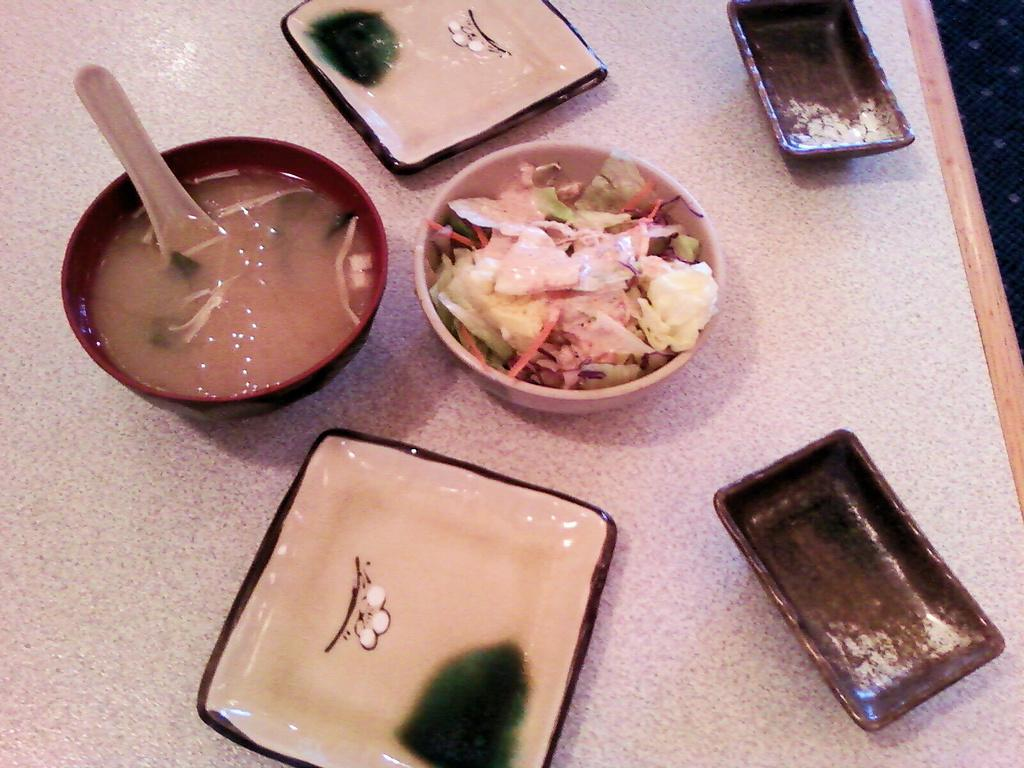What type of dish can be seen in the bowls in the image? The bowls contain soup and salad. How many bowls are visible in the image? The number of bowls is not specified, but there are at least two bowls containing soup and salad. Where are the bowls located in the image? The bowls are placed on a table. Are there any baseball players visible in the image? No, there are no baseball players present in the image. Can you see any deer in the image? No, there are no deer present in the image. 